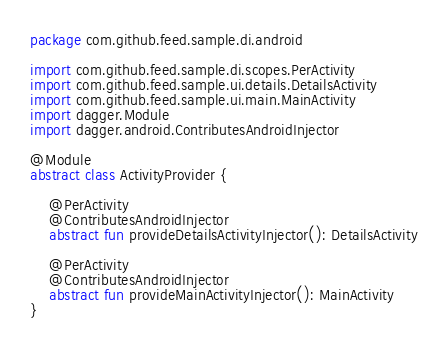Convert code to text. <code><loc_0><loc_0><loc_500><loc_500><_Kotlin_>package com.github.feed.sample.di.android

import com.github.feed.sample.di.scopes.PerActivity
import com.github.feed.sample.ui.details.DetailsActivity
import com.github.feed.sample.ui.main.MainActivity
import dagger.Module
import dagger.android.ContributesAndroidInjector

@Module
abstract class ActivityProvider {

    @PerActivity
    @ContributesAndroidInjector
    abstract fun provideDetailsActivityInjector(): DetailsActivity

    @PerActivity
    @ContributesAndroidInjector
    abstract fun provideMainActivityInjector(): MainActivity
}
</code> 